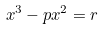Convert formula to latex. <formula><loc_0><loc_0><loc_500><loc_500>x ^ { 3 } - p x ^ { 2 } = r</formula> 